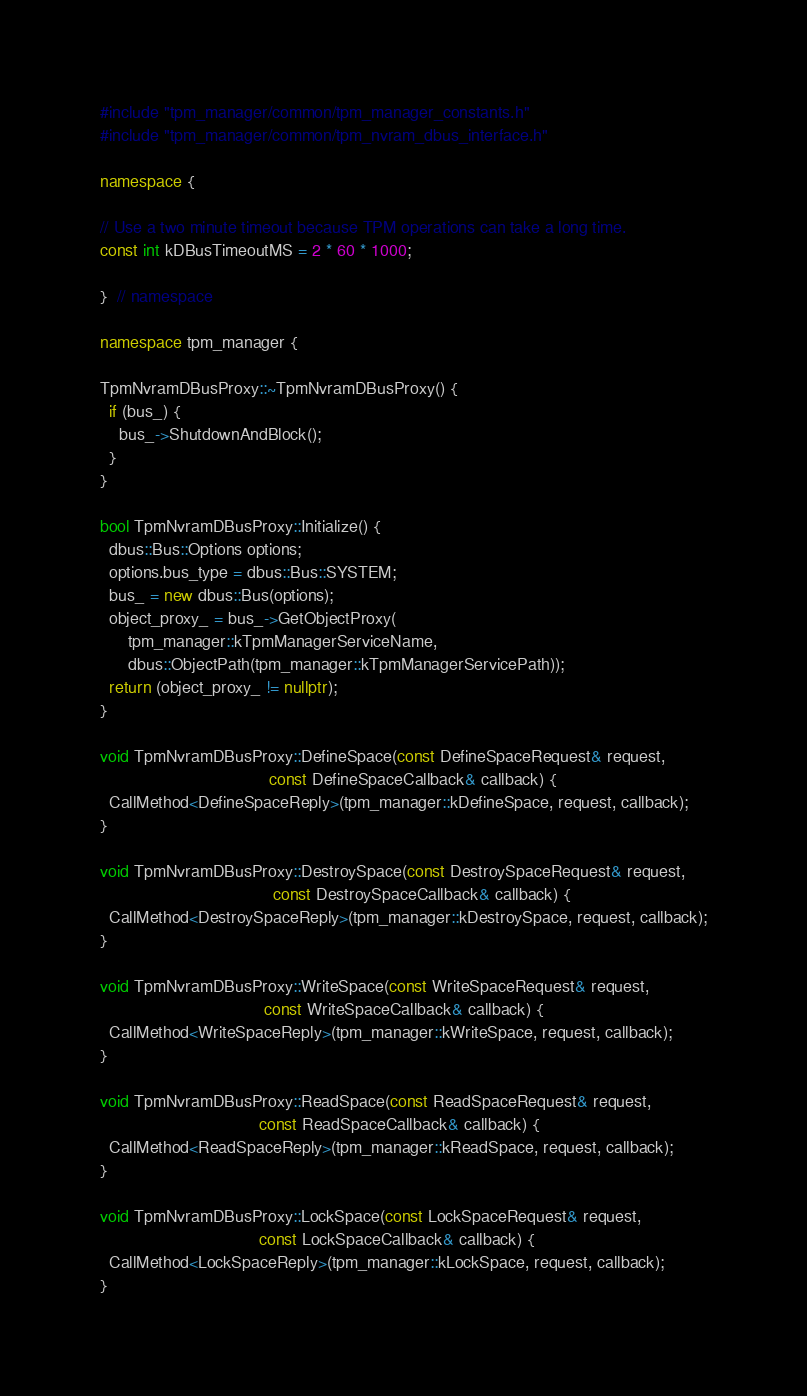<code> <loc_0><loc_0><loc_500><loc_500><_C++_>#include "tpm_manager/common/tpm_manager_constants.h"
#include "tpm_manager/common/tpm_nvram_dbus_interface.h"

namespace {

// Use a two minute timeout because TPM operations can take a long time.
const int kDBusTimeoutMS = 2 * 60 * 1000;

}  // namespace

namespace tpm_manager {

TpmNvramDBusProxy::~TpmNvramDBusProxy() {
  if (bus_) {
    bus_->ShutdownAndBlock();
  }
}

bool TpmNvramDBusProxy::Initialize() {
  dbus::Bus::Options options;
  options.bus_type = dbus::Bus::SYSTEM;
  bus_ = new dbus::Bus(options);
  object_proxy_ = bus_->GetObjectProxy(
      tpm_manager::kTpmManagerServiceName,
      dbus::ObjectPath(tpm_manager::kTpmManagerServicePath));
  return (object_proxy_ != nullptr);
}

void TpmNvramDBusProxy::DefineSpace(const DefineSpaceRequest& request,
                                    const DefineSpaceCallback& callback) {
  CallMethod<DefineSpaceReply>(tpm_manager::kDefineSpace, request, callback);
}

void TpmNvramDBusProxy::DestroySpace(const DestroySpaceRequest& request,
                                     const DestroySpaceCallback& callback) {
  CallMethod<DestroySpaceReply>(tpm_manager::kDestroySpace, request, callback);
}

void TpmNvramDBusProxy::WriteSpace(const WriteSpaceRequest& request,
                                   const WriteSpaceCallback& callback) {
  CallMethod<WriteSpaceReply>(tpm_manager::kWriteSpace, request, callback);
}

void TpmNvramDBusProxy::ReadSpace(const ReadSpaceRequest& request,
                                  const ReadSpaceCallback& callback) {
  CallMethod<ReadSpaceReply>(tpm_manager::kReadSpace, request, callback);
}

void TpmNvramDBusProxy::LockSpace(const LockSpaceRequest& request,
                                  const LockSpaceCallback& callback) {
  CallMethod<LockSpaceReply>(tpm_manager::kLockSpace, request, callback);
}
</code> 